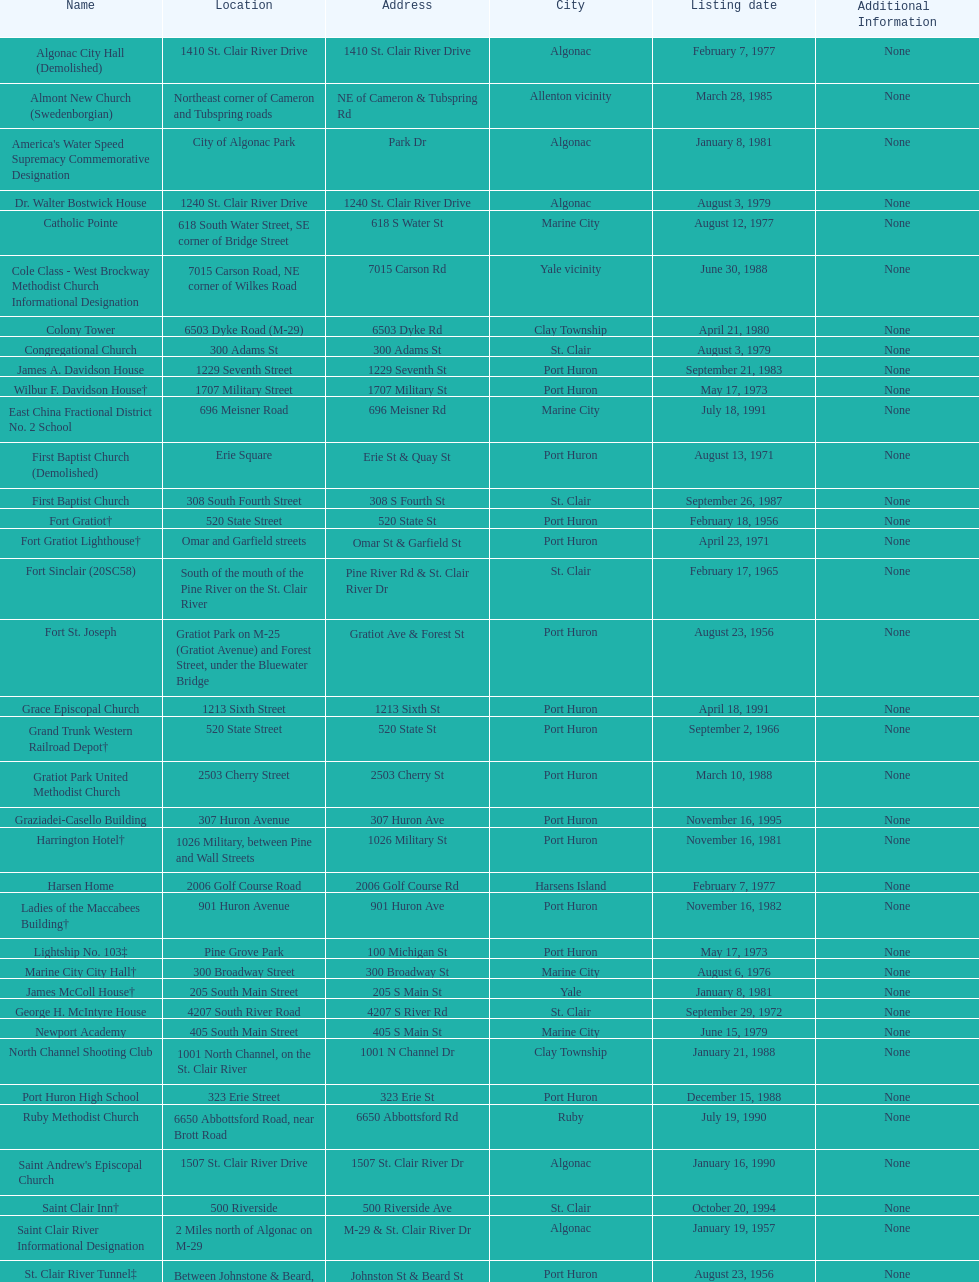What is the number of properties on the list that have been demolished? 2. 